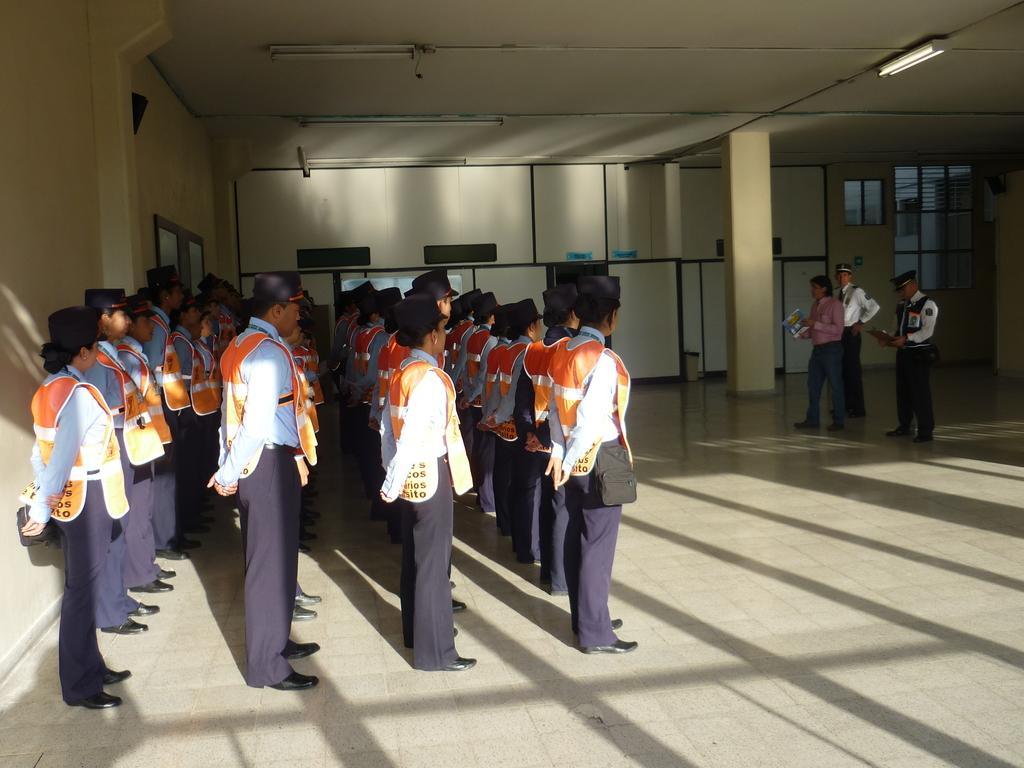What is the primary surface visible in the image? There is a floor in the image. What are the people in the image doing? The people are standing on the floor. What other architectural features can be seen in the image? There is a wall, doors, a window, and a pillar in the image. What is above the people in the image? There is a ceiling in the image. What is attached to the ceiling? There are lights attached to the ceiling. How many dimes can be seen on the floor in the image? There are no dimes visible on the floor in the image. What type of board is being used to measure the height of the pillar in the image? There is no board or measurement activity present in the image. 